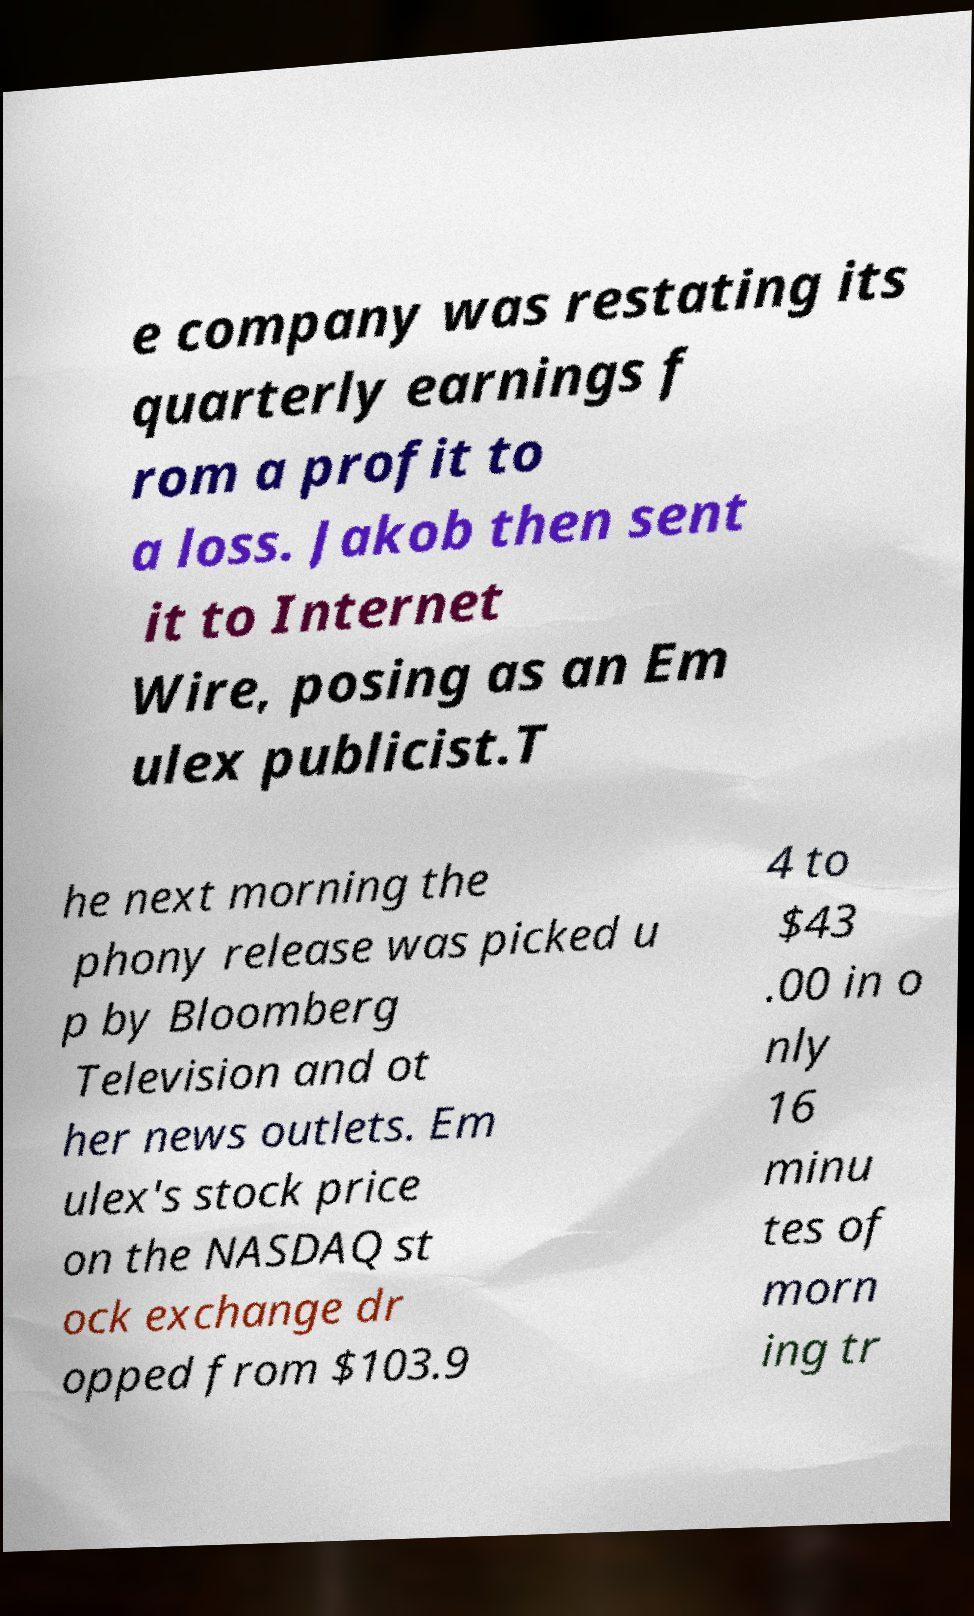What messages or text are displayed in this image? I need them in a readable, typed format. e company was restating its quarterly earnings f rom a profit to a loss. Jakob then sent it to Internet Wire, posing as an Em ulex publicist.T he next morning the phony release was picked u p by Bloomberg Television and ot her news outlets. Em ulex's stock price on the NASDAQ st ock exchange dr opped from $103.9 4 to $43 .00 in o nly 16 minu tes of morn ing tr 